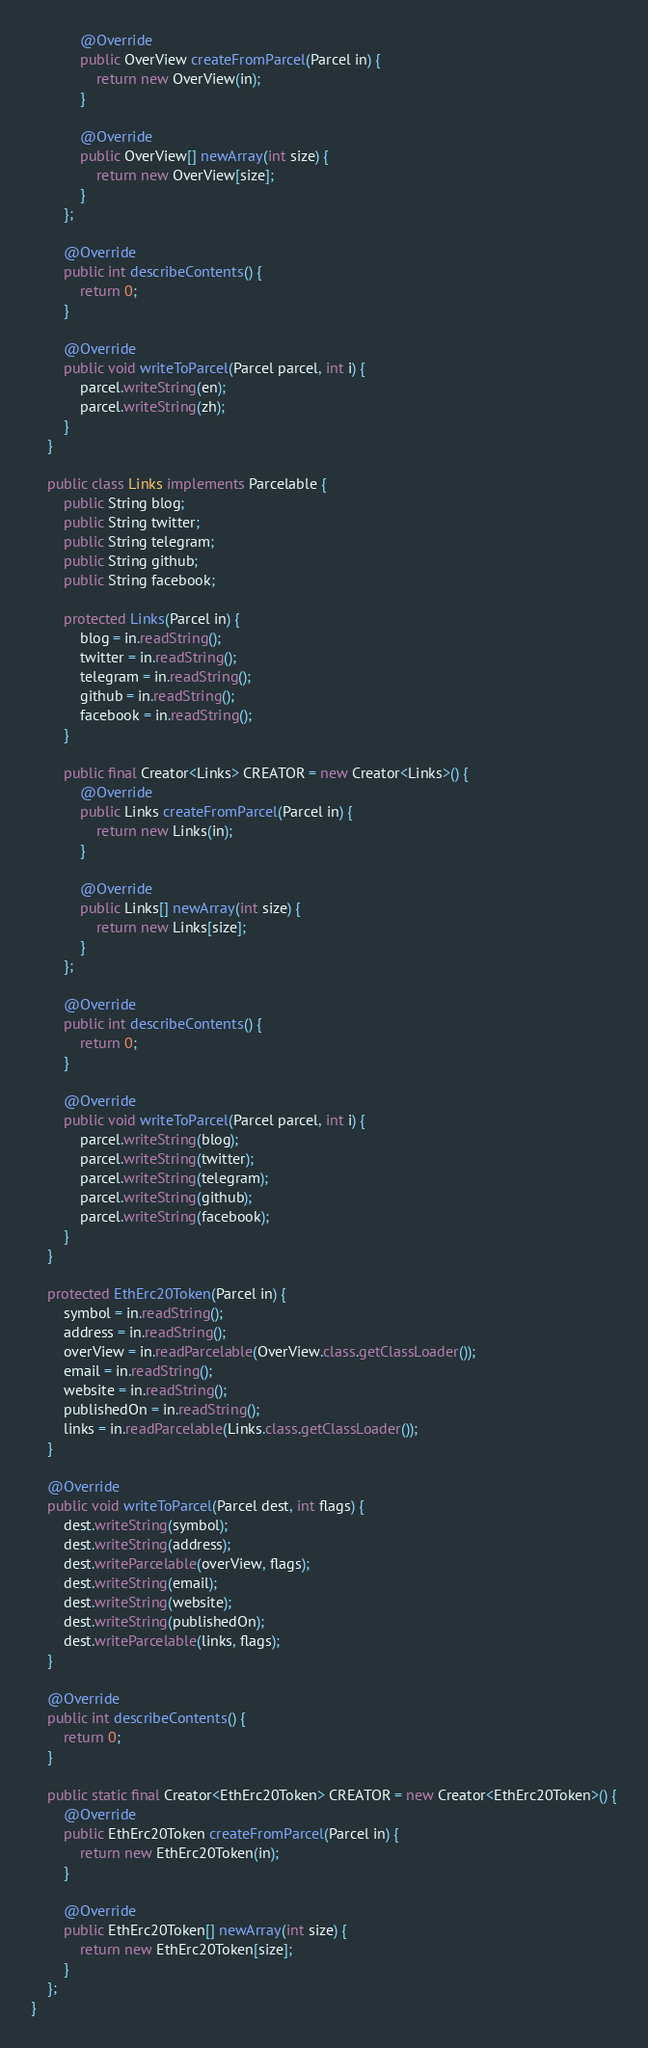Convert code to text. <code><loc_0><loc_0><loc_500><loc_500><_Java_>            @Override
            public OverView createFromParcel(Parcel in) {
                return new OverView(in);
            }

            @Override
            public OverView[] newArray(int size) {
                return new OverView[size];
            }
        };

        @Override
        public int describeContents() {
            return 0;
        }

        @Override
        public void writeToParcel(Parcel parcel, int i) {
            parcel.writeString(en);
            parcel.writeString(zh);
        }
    }

    public class Links implements Parcelable {
        public String blog;
        public String twitter;
        public String telegram;
        public String github;
        public String facebook;

        protected Links(Parcel in) {
            blog = in.readString();
            twitter = in.readString();
            telegram = in.readString();
            github = in.readString();
            facebook = in.readString();
        }

        public final Creator<Links> CREATOR = new Creator<Links>() {
            @Override
            public Links createFromParcel(Parcel in) {
                return new Links(in);
            }

            @Override
            public Links[] newArray(int size) {
                return new Links[size];
            }
        };

        @Override
        public int describeContents() {
            return 0;
        }

        @Override
        public void writeToParcel(Parcel parcel, int i) {
            parcel.writeString(blog);
            parcel.writeString(twitter);
            parcel.writeString(telegram);
            parcel.writeString(github);
            parcel.writeString(facebook);
        }
    }

    protected EthErc20Token(Parcel in) {
        symbol = in.readString();
        address = in.readString();
        overView = in.readParcelable(OverView.class.getClassLoader());
        email = in.readString();
        website = in.readString();
        publishedOn = in.readString();
        links = in.readParcelable(Links.class.getClassLoader());
    }

    @Override
    public void writeToParcel(Parcel dest, int flags) {
        dest.writeString(symbol);
        dest.writeString(address);
        dest.writeParcelable(overView, flags);
        dest.writeString(email);
        dest.writeString(website);
        dest.writeString(publishedOn);
        dest.writeParcelable(links, flags);
    }

    @Override
    public int describeContents() {
        return 0;
    }

    public static final Creator<EthErc20Token> CREATOR = new Creator<EthErc20Token>() {
        @Override
        public EthErc20Token createFromParcel(Parcel in) {
            return new EthErc20Token(in);
        }

        @Override
        public EthErc20Token[] newArray(int size) {
            return new EthErc20Token[size];
        }
    };
}
</code> 